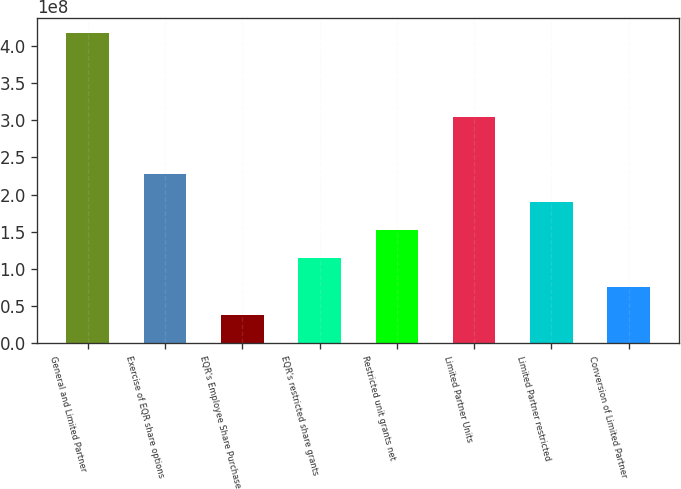Convert chart. <chart><loc_0><loc_0><loc_500><loc_500><bar_chart><fcel>General and Limited Partner<fcel>Exercise of EQR share options<fcel>EQR's Employee Share Purchase<fcel>EQR's restricted share grants<fcel>Restricted unit grants net<fcel>Limited Partner Units<fcel>Limited Partner restricted<fcel>Conversion of Limited Partner<nl><fcel>4.17232e+08<fcel>2.28298e+08<fcel>3.80497e+07<fcel>1.14149e+08<fcel>1.52199e+08<fcel>3.04398e+08<fcel>1.90249e+08<fcel>7.60994e+07<nl></chart> 